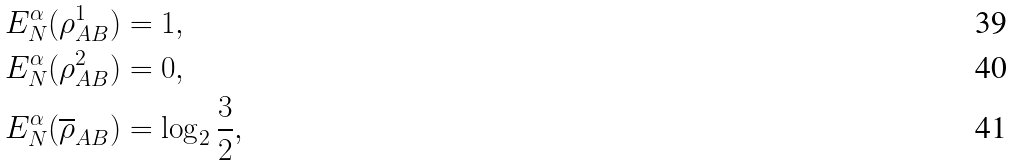<formula> <loc_0><loc_0><loc_500><loc_500>E _ { N } ^ { \alpha } ( \rho _ { A B } ^ { 1 } ) & = 1 , \\ E _ { N } ^ { \alpha } ( \rho _ { A B } ^ { 2 } ) & = 0 , \\ E _ { N } ^ { \alpha } ( \overline { \rho } _ { A B } ) & = \log _ { 2 } \frac { 3 } { 2 } ,</formula> 